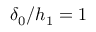<formula> <loc_0><loc_0><loc_500><loc_500>\delta _ { 0 } / h _ { 1 } = 1</formula> 